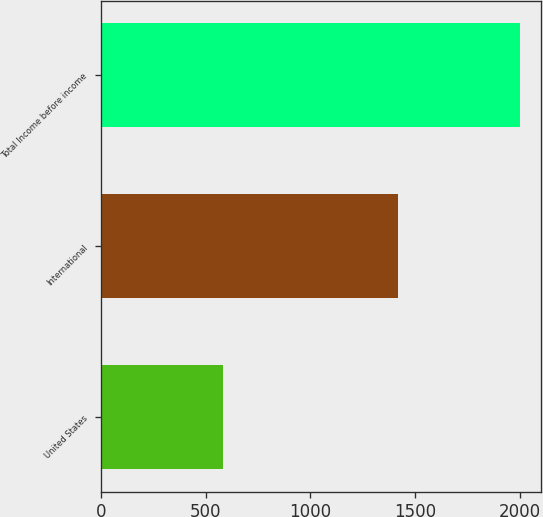Convert chart to OTSL. <chart><loc_0><loc_0><loc_500><loc_500><bar_chart><fcel>United States<fcel>International<fcel>Total Income before income<nl><fcel>584.9<fcel>1416.9<fcel>2001.8<nl></chart> 